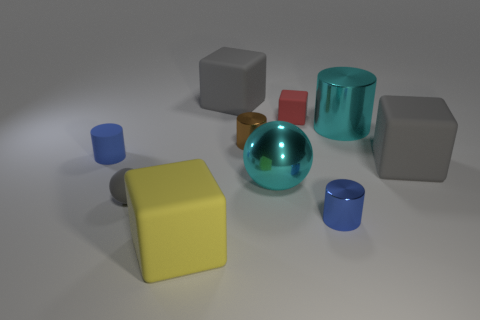Subtract all balls. How many objects are left? 8 Add 8 small gray rubber spheres. How many small gray rubber spheres exist? 9 Subtract 0 purple cylinders. How many objects are left? 10 Subtract all matte spheres. Subtract all big shiny cylinders. How many objects are left? 8 Add 4 large cyan shiny cylinders. How many large cyan shiny cylinders are left? 5 